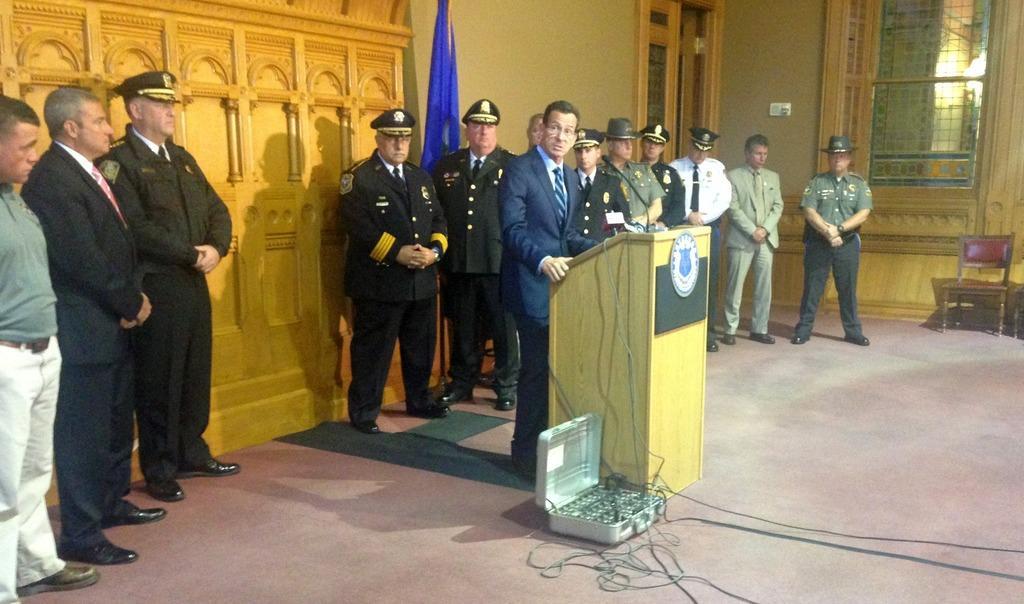Please provide a concise description of this image. In this picture I can observe some men standing on the floor. One of them is standing in front of a podium. In the background I can observe wall. 